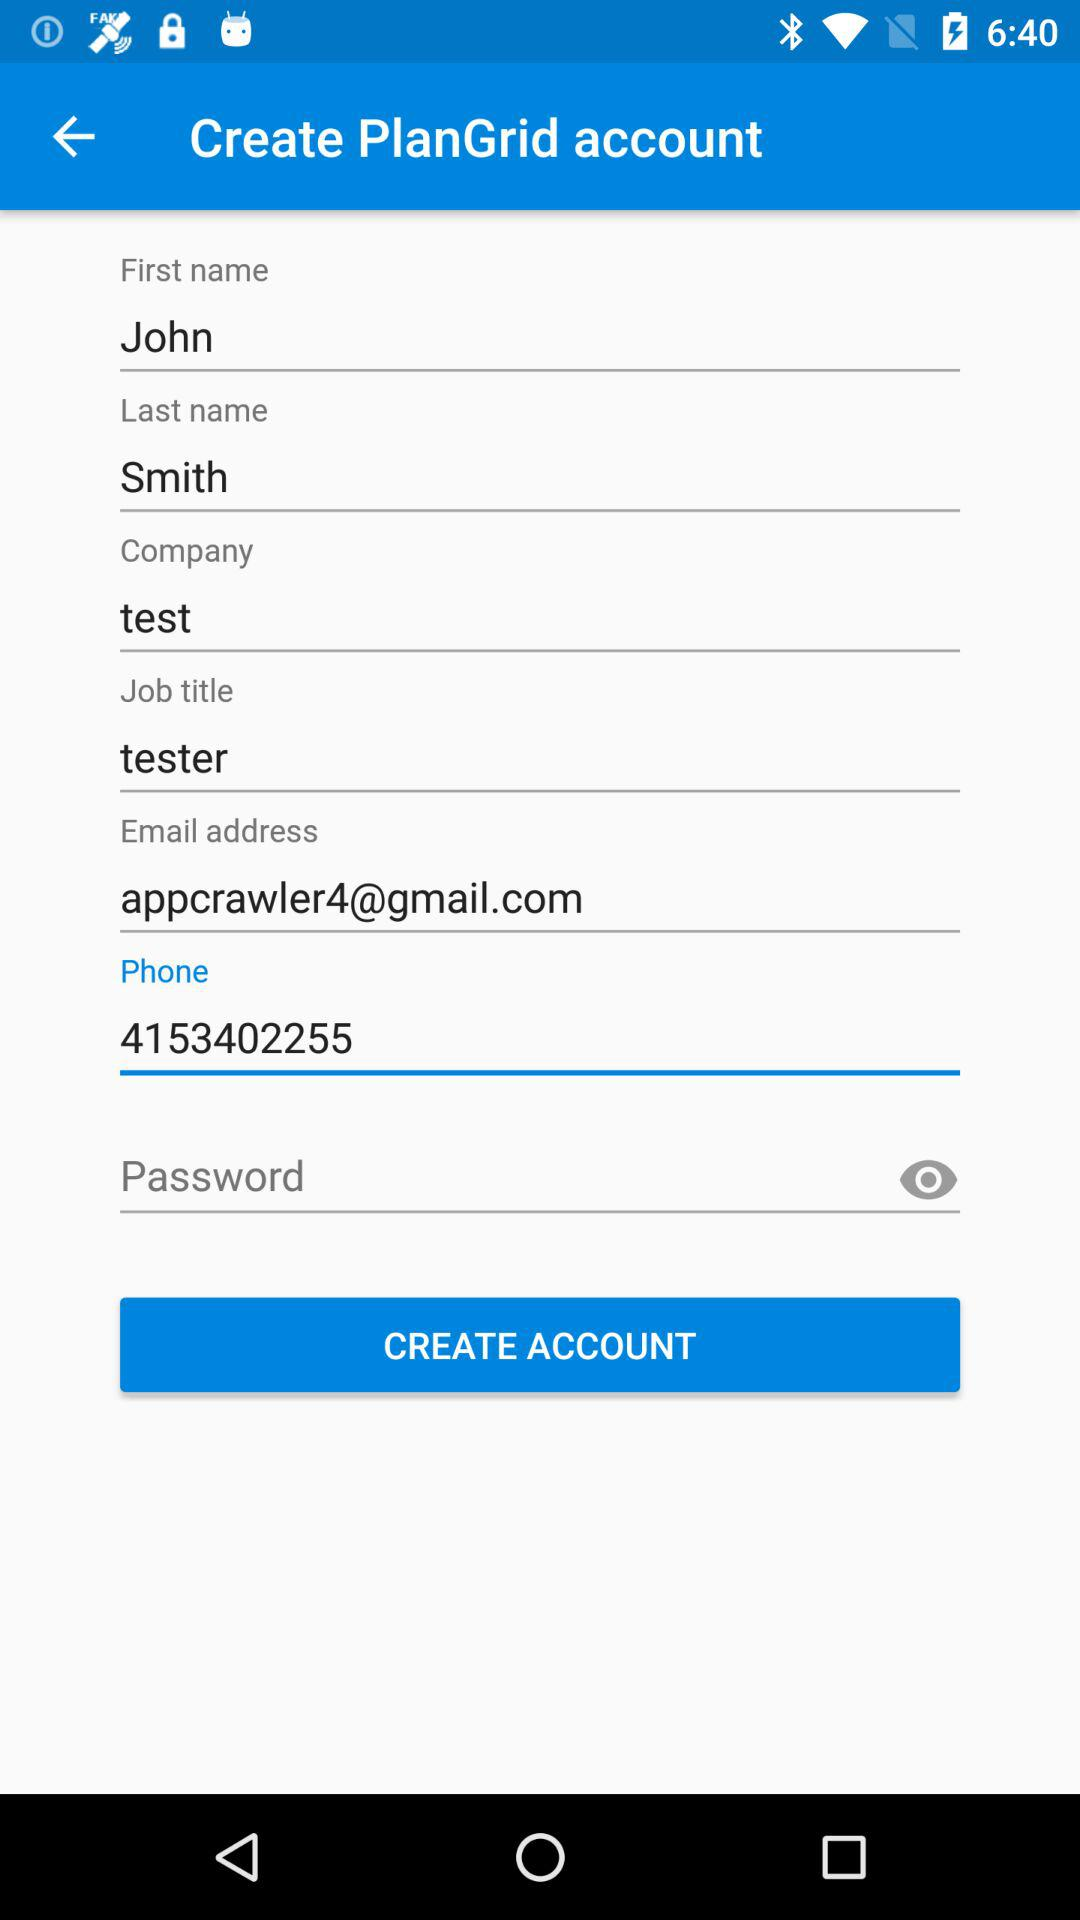Who is the user's employer? The user's employer is "test". 